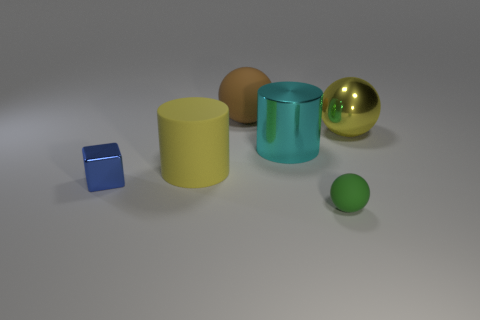What number of green matte balls are in front of the tiny object left of the brown sphere right of the tiny metallic block?
Your answer should be compact. 1. There is a rubber sphere that is in front of the blue metallic object; is it the same size as the ball left of the small green ball?
Your answer should be compact. No. There is a brown object that is the same shape as the green object; what is it made of?
Your response must be concise. Rubber. How many tiny objects are purple rubber spheres or metallic cylinders?
Provide a succinct answer. 0. What is the tiny ball made of?
Your response must be concise. Rubber. There is a thing that is both in front of the large cyan shiny object and on the right side of the big brown matte ball; what material is it?
Provide a succinct answer. Rubber. Does the large metal sphere have the same color as the cylinder that is left of the large matte ball?
Keep it short and to the point. Yes. There is a green ball that is the same size as the metal block; what is its material?
Ensure brevity in your answer.  Rubber. Are there any tiny blue things made of the same material as the brown thing?
Provide a short and direct response. No. What number of small green balls are there?
Make the answer very short. 1. 